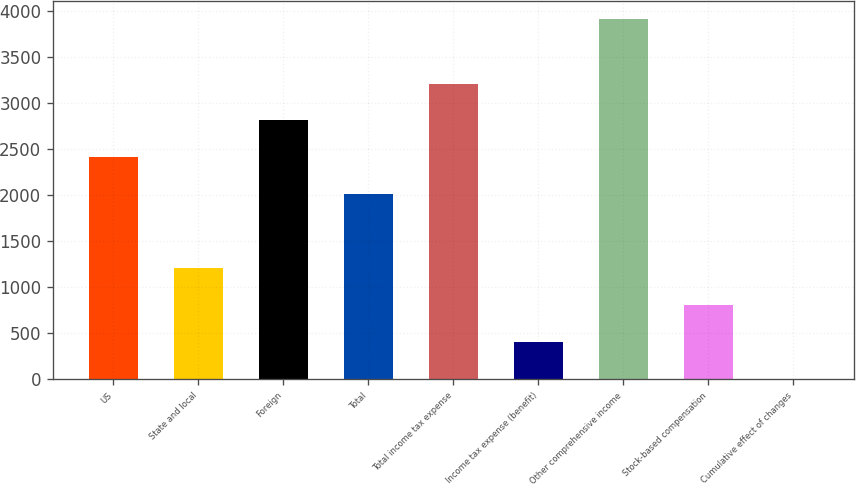Convert chart. <chart><loc_0><loc_0><loc_500><loc_500><bar_chart><fcel>US<fcel>State and local<fcel>Foreign<fcel>Total<fcel>Total income tax expense<fcel>Income tax expense (benefit)<fcel>Other comprehensive income<fcel>Stock-based compensation<fcel>Cumulative effect of changes<nl><fcel>2410<fcel>1208.5<fcel>2810.5<fcel>2009.5<fcel>3211<fcel>407.5<fcel>3912<fcel>808<fcel>7<nl></chart> 